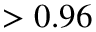Convert formula to latex. <formula><loc_0><loc_0><loc_500><loc_500>> 0 . 9 6</formula> 